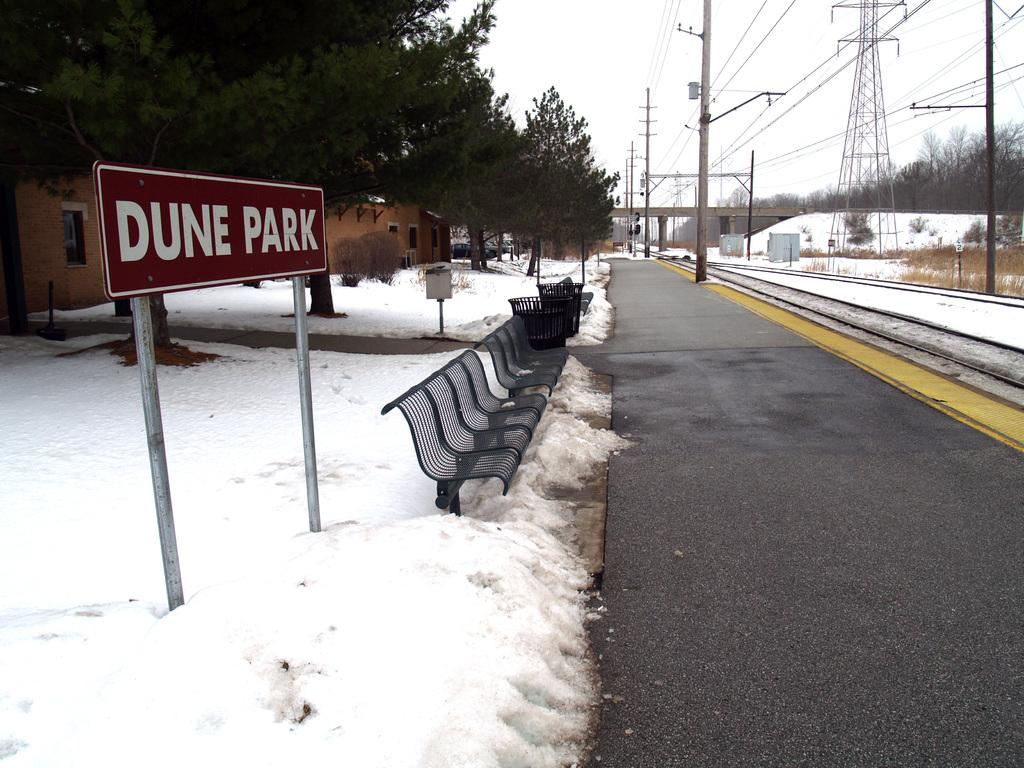What is the weather condition in the image? There is snow in the image, indicating a cold weather condition. What type of furniture can be seen in the image? There are chairs in the image. What objects are used for waste disposal in the image? Dustbins are present in the image. What type of vegetation is visible in the image? There are trees in the image. What type of structures are visible in the image? There are buildings in the image. What type of poles are visible in the image? Current poles are visible in the image. What is visible at the top of the image? The sky is visible at the top of the image. How many lizards can be seen crawling on the buildings in the image? There are no lizards visible in the image; it features snow, chairs, dustbins, trees, buildings, current poles, and the sky. What type of mine is present in the image? There is no mine present in the image. 